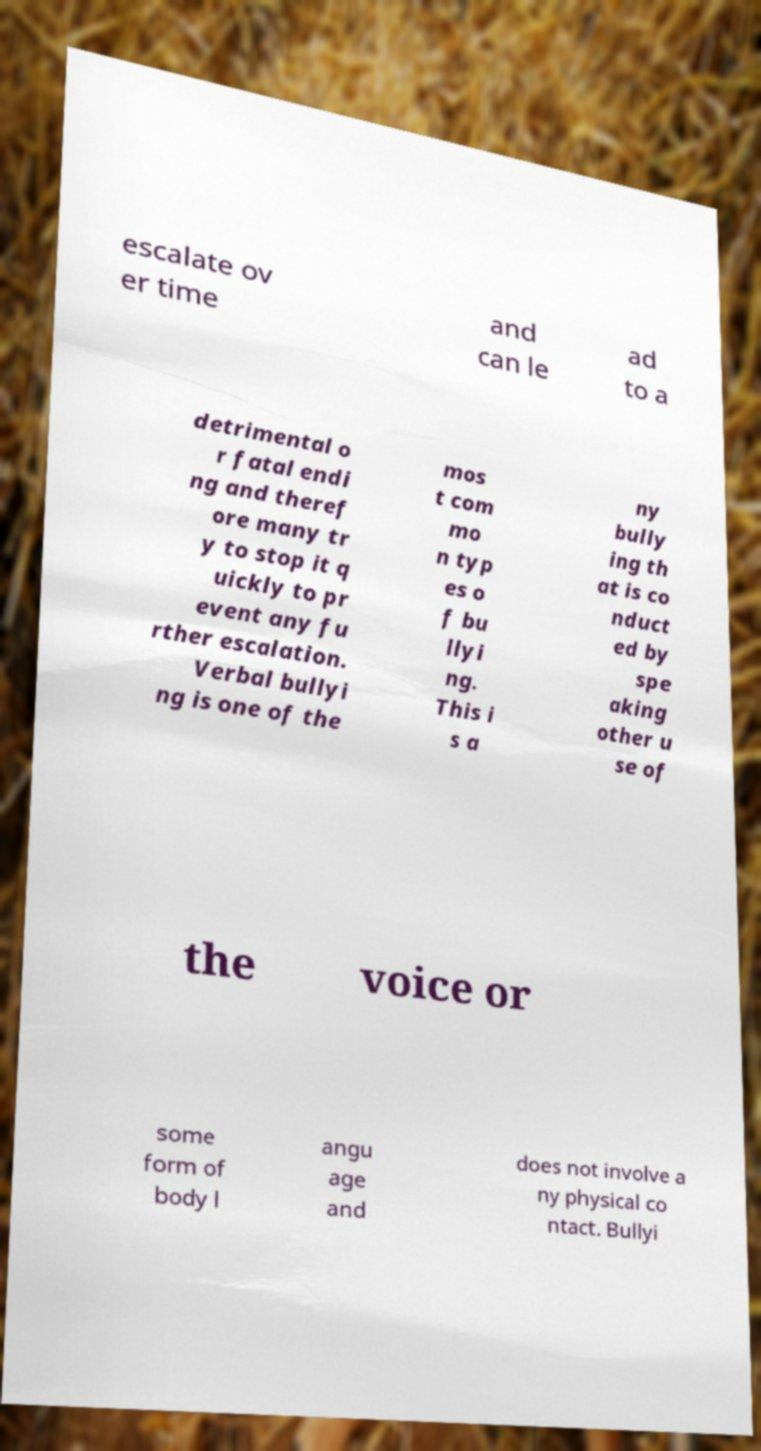Can you read and provide the text displayed in the image?This photo seems to have some interesting text. Can you extract and type it out for me? escalate ov er time and can le ad to a detrimental o r fatal endi ng and theref ore many tr y to stop it q uickly to pr event any fu rther escalation. Verbal bullyi ng is one of the mos t com mo n typ es o f bu llyi ng. This i s a ny bully ing th at is co nduct ed by spe aking other u se of the voice or some form of body l angu age and does not involve a ny physical co ntact. Bullyi 